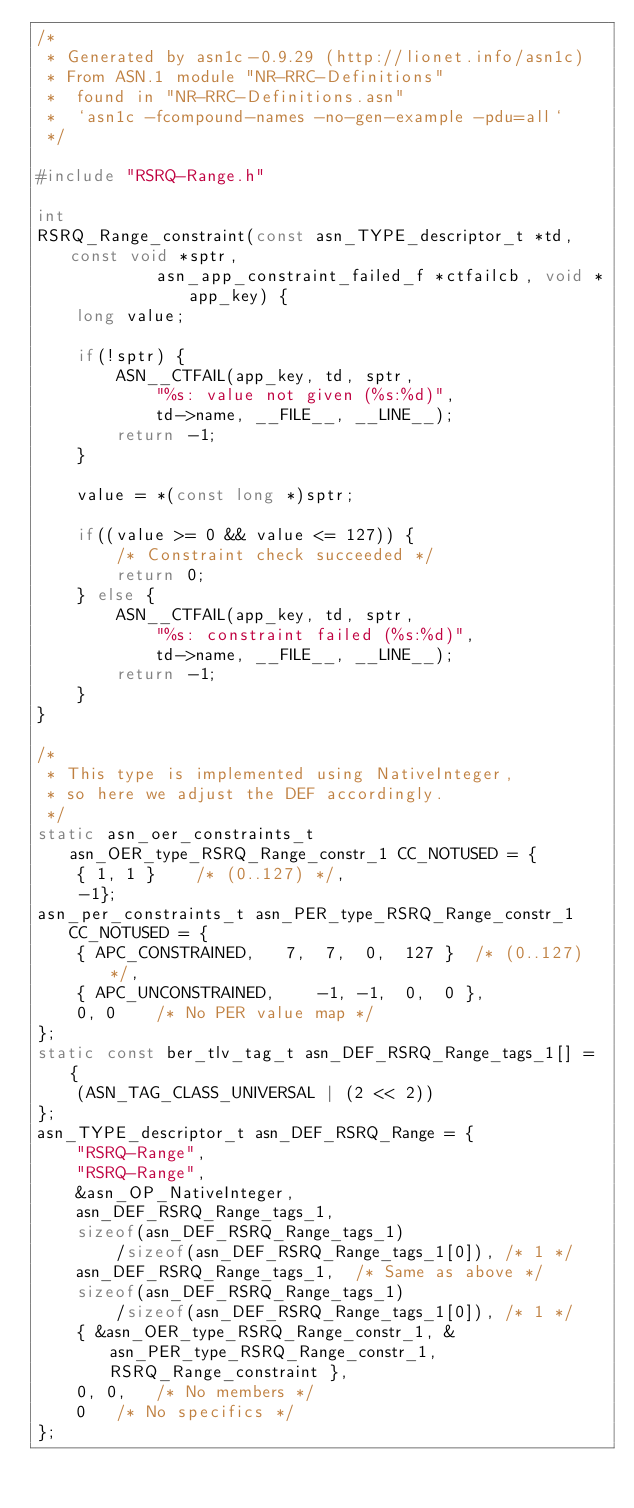Convert code to text. <code><loc_0><loc_0><loc_500><loc_500><_C_>/*
 * Generated by asn1c-0.9.29 (http://lionet.info/asn1c)
 * From ASN.1 module "NR-RRC-Definitions"
 * 	found in "NR-RRC-Definitions.asn"
 * 	`asn1c -fcompound-names -no-gen-example -pdu=all`
 */

#include "RSRQ-Range.h"

int
RSRQ_Range_constraint(const asn_TYPE_descriptor_t *td, const void *sptr,
			asn_app_constraint_failed_f *ctfailcb, void *app_key) {
	long value;
	
	if(!sptr) {
		ASN__CTFAIL(app_key, td, sptr,
			"%s: value not given (%s:%d)",
			td->name, __FILE__, __LINE__);
		return -1;
	}
	
	value = *(const long *)sptr;
	
	if((value >= 0 && value <= 127)) {
		/* Constraint check succeeded */
		return 0;
	} else {
		ASN__CTFAIL(app_key, td, sptr,
			"%s: constraint failed (%s:%d)",
			td->name, __FILE__, __LINE__);
		return -1;
	}
}

/*
 * This type is implemented using NativeInteger,
 * so here we adjust the DEF accordingly.
 */
static asn_oer_constraints_t asn_OER_type_RSRQ_Range_constr_1 CC_NOTUSED = {
	{ 1, 1 }	/* (0..127) */,
	-1};
asn_per_constraints_t asn_PER_type_RSRQ_Range_constr_1 CC_NOTUSED = {
	{ APC_CONSTRAINED,	 7,  7,  0,  127 }	/* (0..127) */,
	{ APC_UNCONSTRAINED,	-1, -1,  0,  0 },
	0, 0	/* No PER value map */
};
static const ber_tlv_tag_t asn_DEF_RSRQ_Range_tags_1[] = {
	(ASN_TAG_CLASS_UNIVERSAL | (2 << 2))
};
asn_TYPE_descriptor_t asn_DEF_RSRQ_Range = {
	"RSRQ-Range",
	"RSRQ-Range",
	&asn_OP_NativeInteger,
	asn_DEF_RSRQ_Range_tags_1,
	sizeof(asn_DEF_RSRQ_Range_tags_1)
		/sizeof(asn_DEF_RSRQ_Range_tags_1[0]), /* 1 */
	asn_DEF_RSRQ_Range_tags_1,	/* Same as above */
	sizeof(asn_DEF_RSRQ_Range_tags_1)
		/sizeof(asn_DEF_RSRQ_Range_tags_1[0]), /* 1 */
	{ &asn_OER_type_RSRQ_Range_constr_1, &asn_PER_type_RSRQ_Range_constr_1, RSRQ_Range_constraint },
	0, 0,	/* No members */
	0	/* No specifics */
};

</code> 